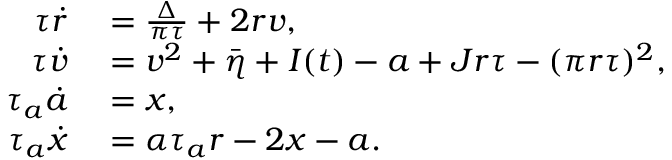<formula> <loc_0><loc_0><loc_500><loc_500>\begin{array} { r l } { \tau \dot { r } } & = \frac { \Delta } { \pi \tau } + 2 r v , } \\ { \tau \dot { v } } & = v ^ { 2 } + \bar { \eta } + I ( t ) - a + J r \tau - ( \pi r \tau ) ^ { 2 } , } \\ { \tau _ { a } \dot { a } } & = x , } \\ { \tau _ { a } \dot { x } } & = \alpha \tau _ { a } r - 2 x - a . } \end{array}</formula> 